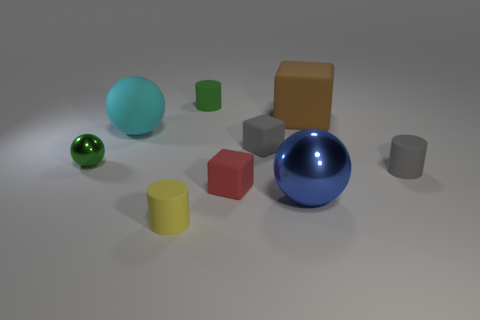Add 1 shiny balls. How many objects exist? 10 Subtract all cylinders. How many objects are left? 6 Add 2 large metallic objects. How many large metallic objects exist? 3 Subtract 0 purple cubes. How many objects are left? 9 Subtract all brown cubes. Subtract all tiny red objects. How many objects are left? 7 Add 2 red objects. How many red objects are left? 3 